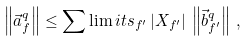<formula> <loc_0><loc_0><loc_500><loc_500>\left \| \vec { a } ^ { q } _ { f } \right \| \leq \sum \lim i t s _ { f ^ { \prime } } \left | X _ { f ^ { \prime } } \right | \, \left \| \vec { b } ^ { q } _ { f ^ { \prime } } \right \| \, ,</formula> 